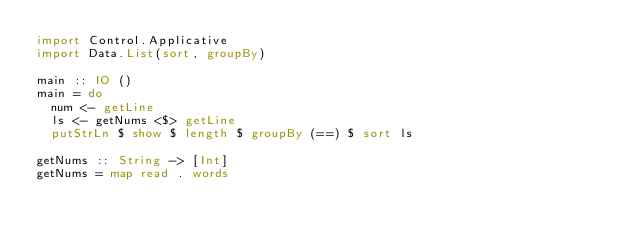Convert code to text. <code><loc_0><loc_0><loc_500><loc_500><_Haskell_>import Control.Applicative
import Data.List(sort, groupBy)

main :: IO ()
main = do
  num <- getLine
  ls <- getNums <$> getLine
  putStrLn $ show $ length $ groupBy (==) $ sort ls

getNums :: String -> [Int]
getNums = map read . words
</code> 